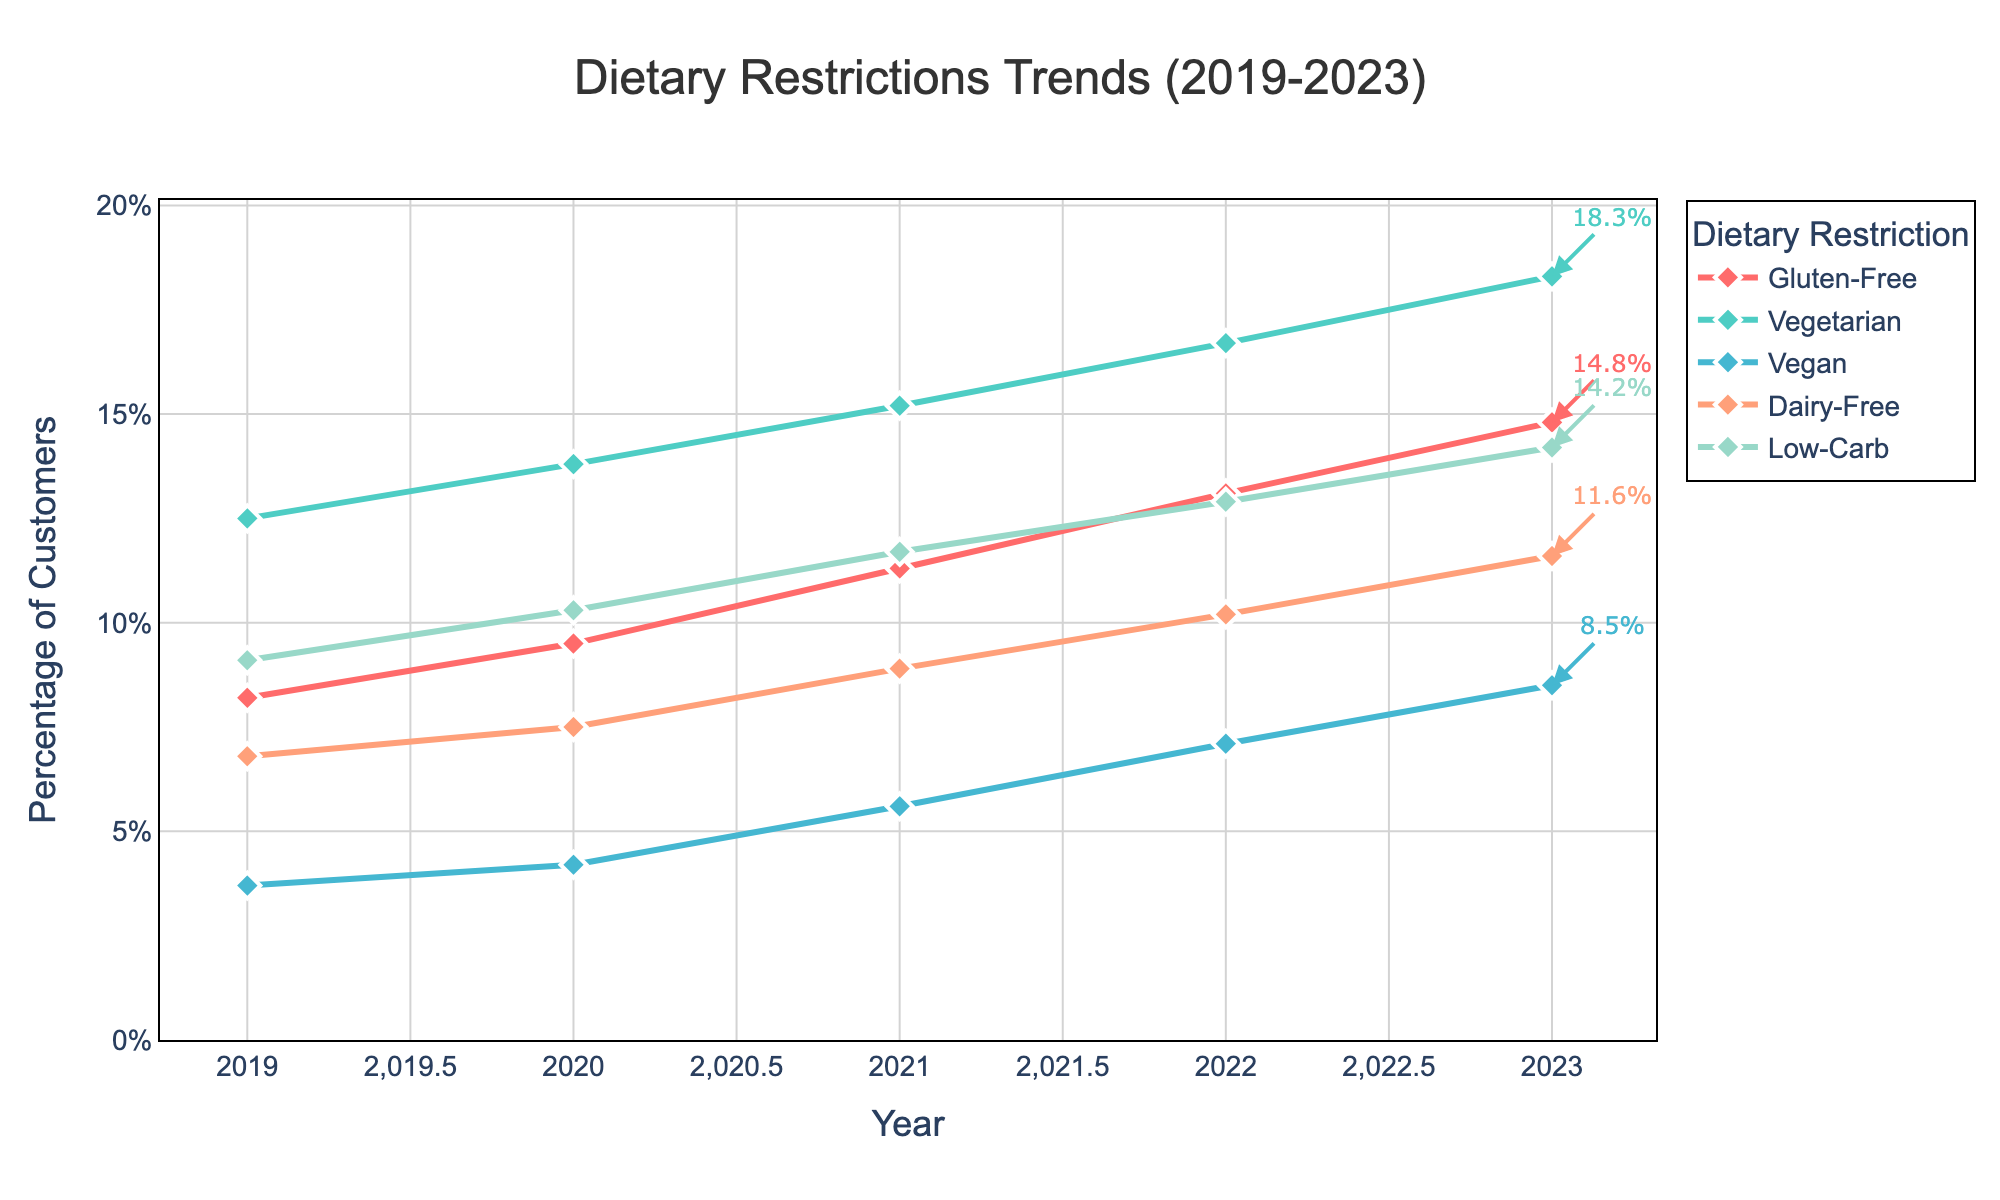What was the difference in the percentage of customers following a gluten-free diet between 2019 and 2023? First, find the percentage of gluten-free customers in 2019 (8.2%) and in 2023 (14.8%). Subtract the 2019 value from the 2023 value: 14.8% - 8.2% = 6.6%
Answer: 6.6% Which dietary restriction saw the largest increase in the percentage of customers from 2019 to 2023? Calculate the increase for each restriction:  
- Gluten-Free: 14.8% - 8.2% = 6.6%
- Vegetarian: 18.3% - 12.5% = 5.8%
- Vegan: 8.5% - 3.7% = 4.8%
- Dairy-Free: 11.6% - 6.8% = 4.8%
- Low-Carb: 14.2% - 9.1% = 5.1%  
The largest increase is for Gluten-Free with 6.6%
Answer: Gluten-Free Which dietary restrictions have a percentage of customers exceeding 10% in 2023? Look at the data for 2023:  
- Gluten-Free: 14.8%
- Vegetarian: 18.3%
- Vegan: 8.5%
- Dairy-Free: 11.6%
- Low-Carb: 14.2%  
The percentages exceeding 10% are for Gluten-Free, Vegetarian, Dairy-Free, and Low-Carb.
Answer: Gluten-Free, Vegetarian, Dairy-Free, Low-Carb Compare the trends of Vegan and Dairy-Free diets over the 5 years. Which one had a steeper increase? Calculate the total increase from 2019 to 2023:  
- Vegan: 8.5% - 3.7% = 4.8%
- Dairy-Free: 11.6% - 6.8% = 4.8%  
Both Vegan and Dairy-Free had the same increase of 4.8%, so neither had a steeper trend.
Answer: Both are equal What is the average percentage of customers following a Low-Carb diet over these five years? Add the percentages for the Low-Carb diet from 2019 to 2023 and divide by 5:  
(9.1 + 10.3 + 11.7 + 12.9 + 14.2) / 5 = 58.2 / 5 = 11.64
Answer: 11.64 Which dietary restriction had the lowest percentage of customers in 2021? Look at the data for 2021 and identify the lowest value:  
- Gluten-Free: 11.3%
- Vegetarian: 15.2%
- Vegan: 5.6%
- Dairy-Free: 8.9%
- Low-Carb: 11.7%  
The lowest percentage is for Vegan at 5.6%.
Answer: Vegan What is the total percentage increase for all dietary restrictions combined from 2019 to 2023? Calculate the total percentage for each year:  
- 2019: 8.2 + 12.5 + 3.7 + 6.8 + 9.1 = 40.3%
- 2023: 14.8 + 18.3 + 8.5 + 11.6 + 14.2 = 67.4%  
Subtract the total percentage for 2019 from 2023: 67.4% - 40.3% = 27.1%
Answer: 27.1% 